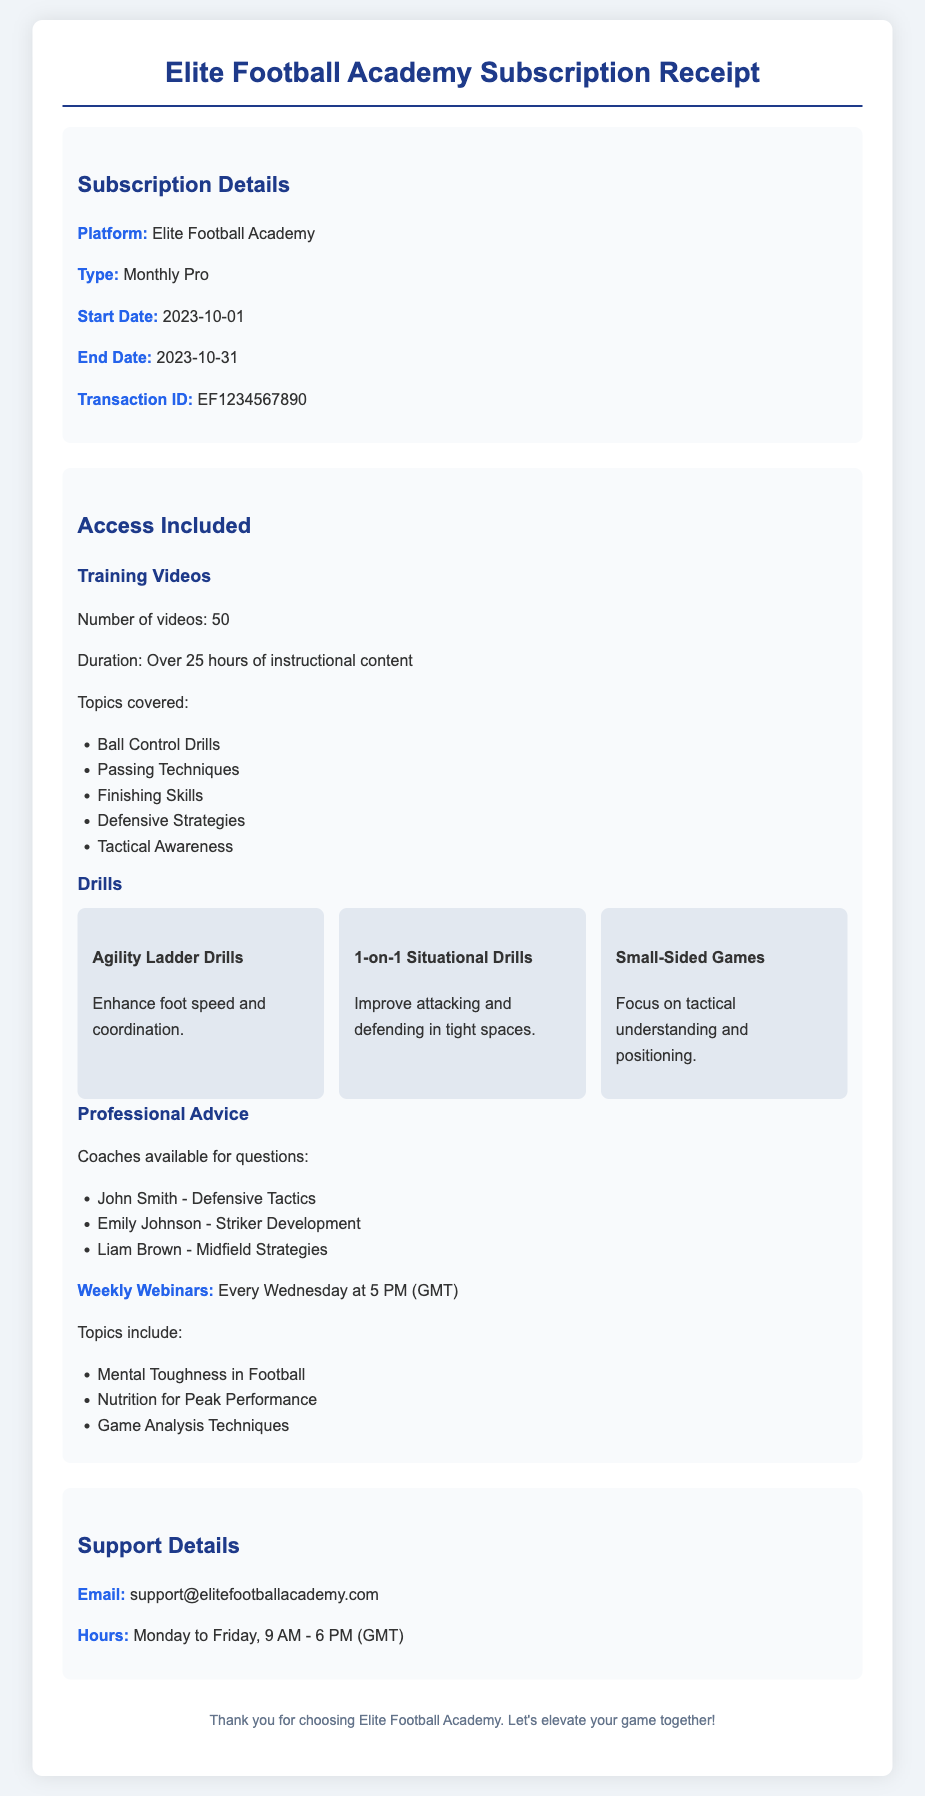What is the platform name? The platform name is specified in the document under subscription details.
Answer: Elite Football Academy What is the subscription type? The subscription type is mentioned directly in the subscription details.
Answer: Monthly Pro When does the subscription start? The start date is clearly indicated in the subscription details.
Answer: 2023-10-01 How many training videos are included? The number of training videos is specified in the "Access Included" section.
Answer: 50 Who provides advice on defensive tactics? The professional advice section lists the coaches available and their specialties.
Answer: John Smith What is the duration of the training videos? The total duration of the training videos is mentioned in the "Access Included" section.
Answer: Over 25 hours When are the weekly webinars scheduled? The timing of the weekly webinars is provided under professional advice.
Answer: Every Wednesday at 5 PM (GMT) How many drills are listed in the document? The drills are mentioned in the "Drills" section, counting the specific drills shown.
Answer: 3 What is the support email address? The support email is given in the "Support Details" section of the document.
Answer: support@elitefootballacademy.com 